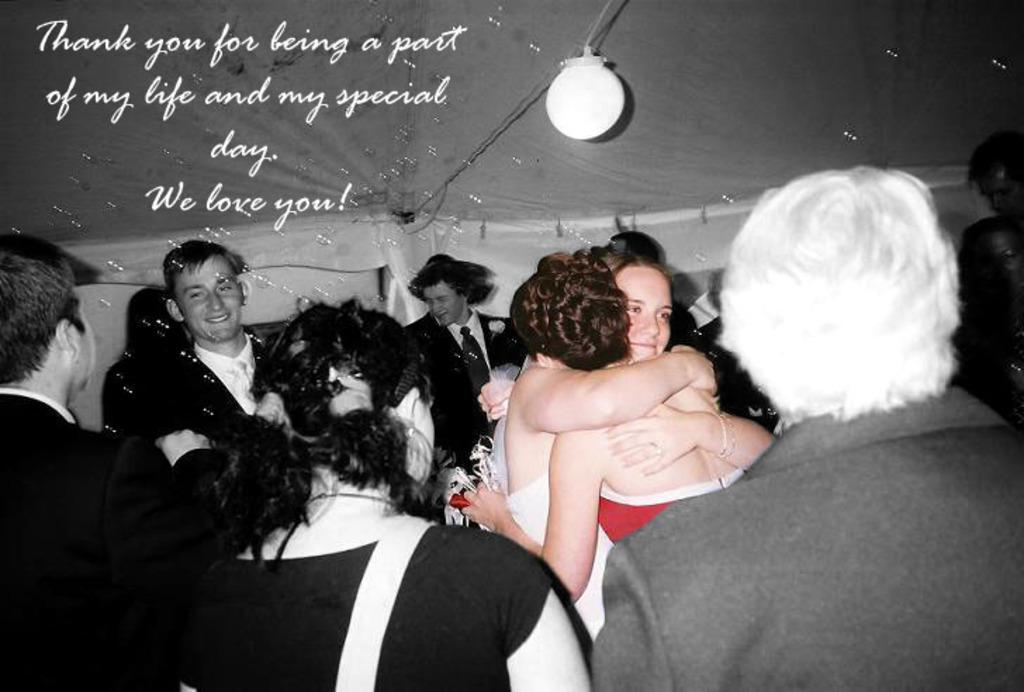How many individuals are visible in the image? There are many people in the image. What are the people wearing? The people are wearing clothes. Is there any text or logo visible in the image? Yes, there is a watermark in the image. What type of illumination is present in the image? There is a light in the image. What kind of decorative items can be seen in the image? Foam balloons are present in the image. What type of pain is being expressed by the people in the image? There is no indication of pain in the image; the people appear to be enjoying themselves or engaged in an activity. 